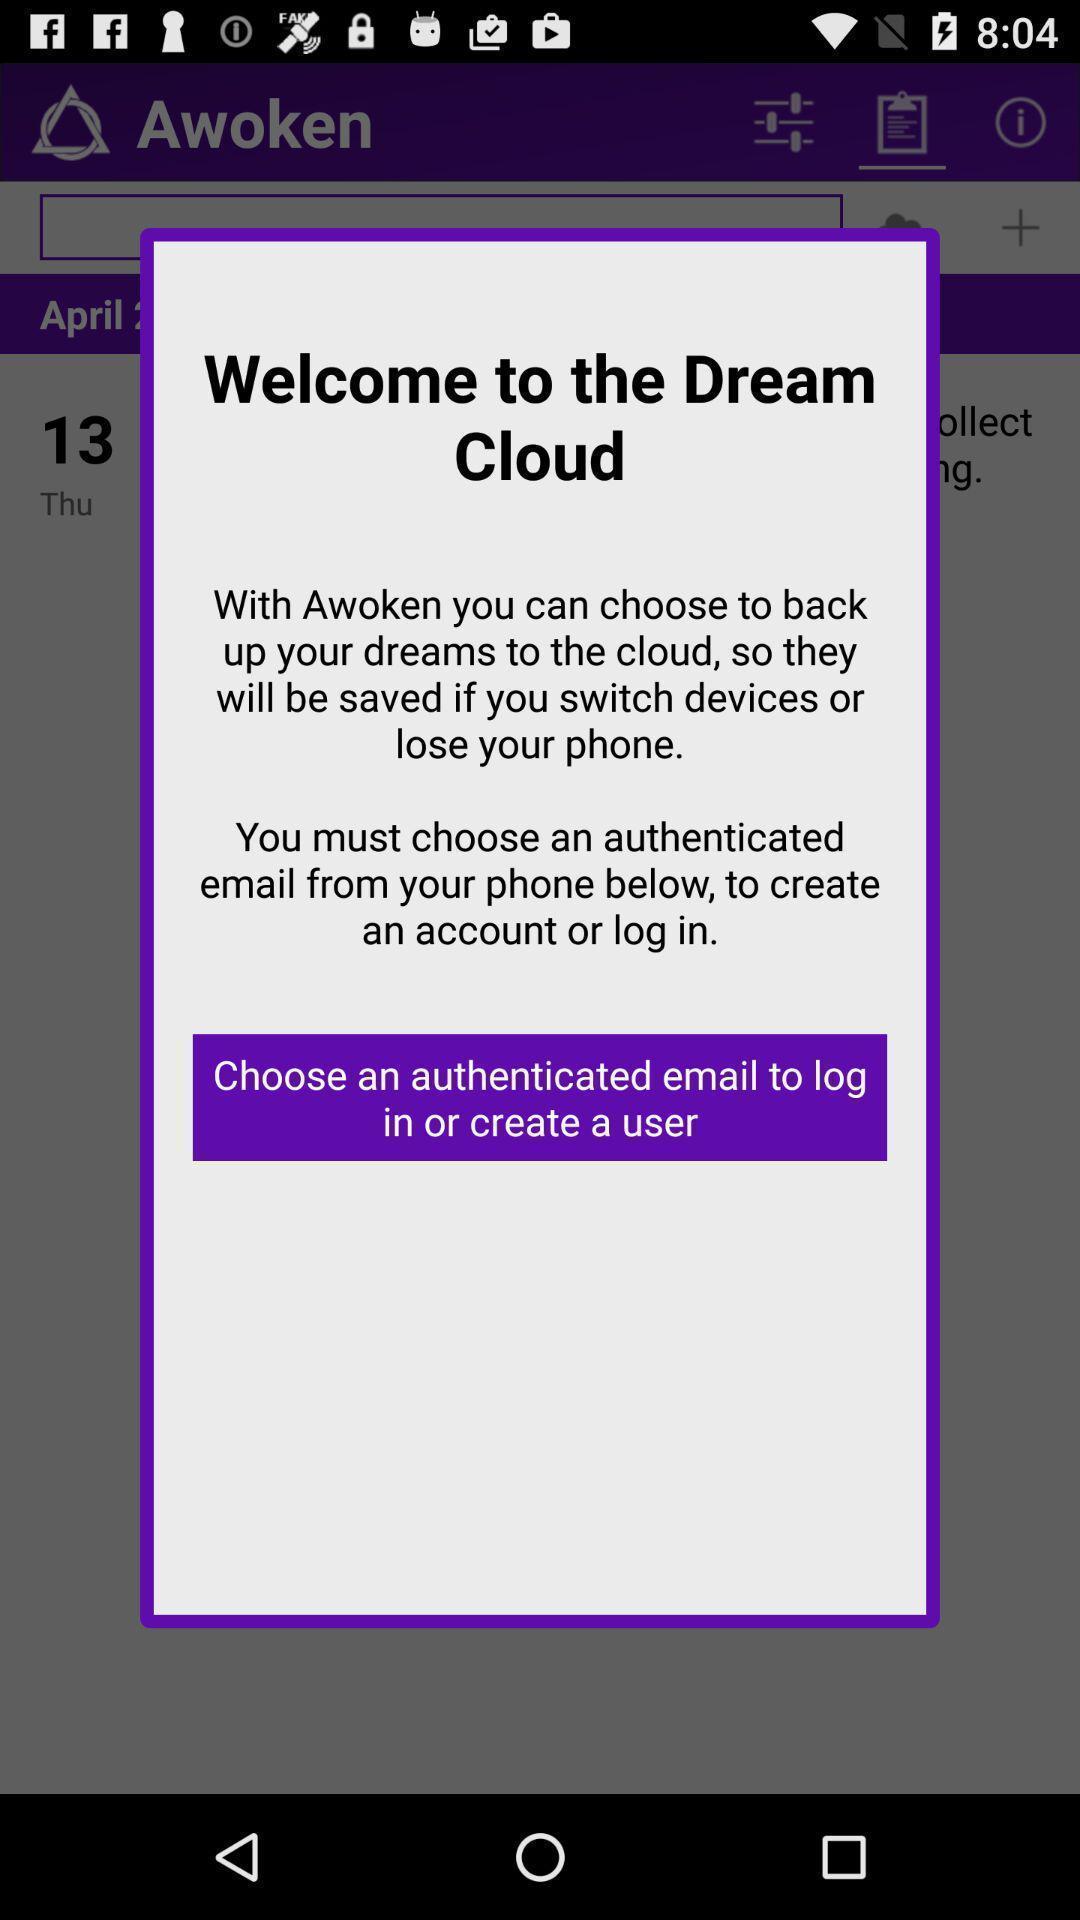What details can you identify in this image? Welcome pop up window. 